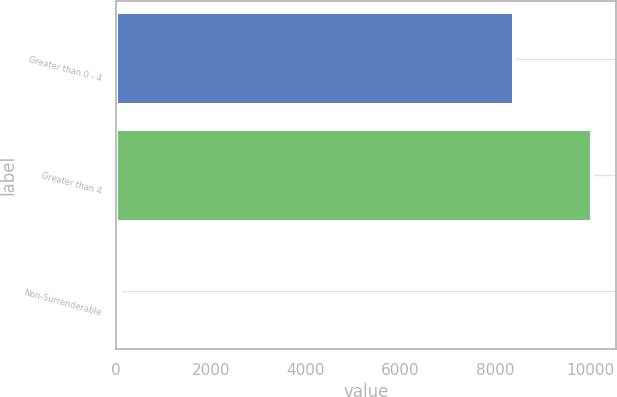Convert chart to OTSL. <chart><loc_0><loc_0><loc_500><loc_500><bar_chart><fcel>Greater than 0 - 4<fcel>Greater than 4<fcel>Non-Surrenderable<nl><fcel>8386<fcel>10035<fcel>81<nl></chart> 